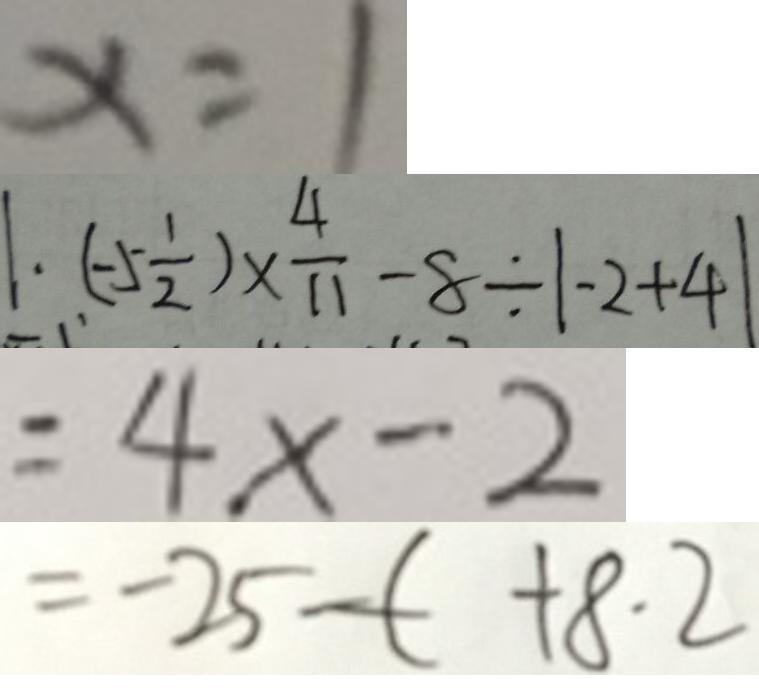Convert formula to latex. <formula><loc_0><loc_0><loc_500><loc_500>x = 1 
 1 . ( - 5 \frac { 1 } { 2 } ) \times \frac { 4 } { 1 1 } - 8 \div \vert - 2 + 4 \vert 
 = 4 x - 2 
 = - 2 5 - ( + 8 . 2</formula> 